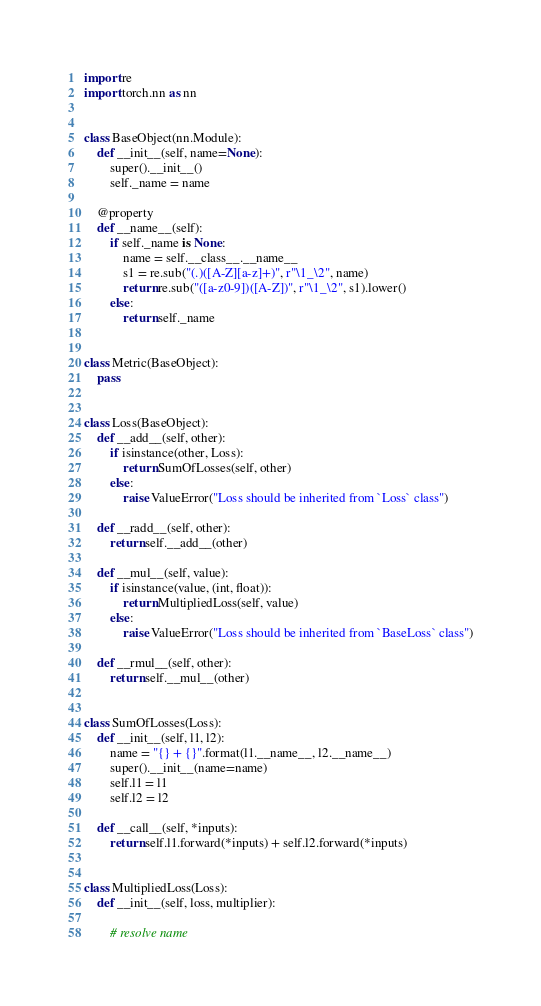Convert code to text. <code><loc_0><loc_0><loc_500><loc_500><_Python_>import re
import torch.nn as nn


class BaseObject(nn.Module):
    def __init__(self, name=None):
        super().__init__()
        self._name = name

    @property
    def __name__(self):
        if self._name is None:
            name = self.__class__.__name__
            s1 = re.sub("(.)([A-Z][a-z]+)", r"\1_\2", name)
            return re.sub("([a-z0-9])([A-Z])", r"\1_\2", s1).lower()
        else:
            return self._name


class Metric(BaseObject):
    pass


class Loss(BaseObject):
    def __add__(self, other):
        if isinstance(other, Loss):
            return SumOfLosses(self, other)
        else:
            raise ValueError("Loss should be inherited from `Loss` class")

    def __radd__(self, other):
        return self.__add__(other)

    def __mul__(self, value):
        if isinstance(value, (int, float)):
            return MultipliedLoss(self, value)
        else:
            raise ValueError("Loss should be inherited from `BaseLoss` class")

    def __rmul__(self, other):
        return self.__mul__(other)


class SumOfLosses(Loss):
    def __init__(self, l1, l2):
        name = "{} + {}".format(l1.__name__, l2.__name__)
        super().__init__(name=name)
        self.l1 = l1
        self.l2 = l2

    def __call__(self, *inputs):
        return self.l1.forward(*inputs) + self.l2.forward(*inputs)


class MultipliedLoss(Loss):
    def __init__(self, loss, multiplier):

        # resolve name</code> 